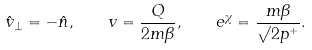Convert formula to latex. <formula><loc_0><loc_0><loc_500><loc_500>\hat { v } _ { \perp } = - \hat { n } , \quad v = \frac { Q } { 2 m \beta } , \quad e ^ { \chi } = \frac { m \beta } { \surd 2 p ^ { + } } .</formula> 